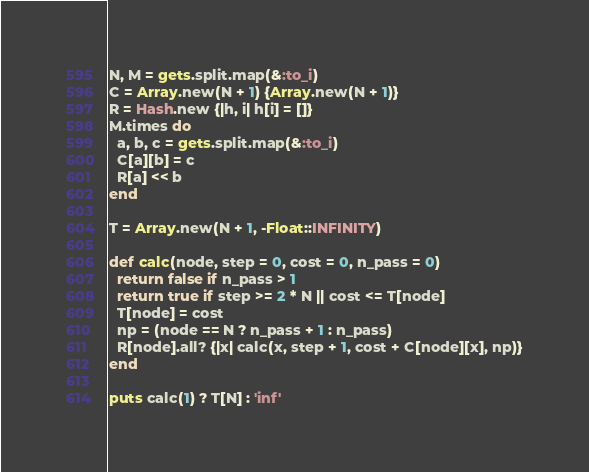<code> <loc_0><loc_0><loc_500><loc_500><_Ruby_>N, M = gets.split.map(&:to_i)
C = Array.new(N + 1) {Array.new(N + 1)}
R = Hash.new {|h, i| h[i] = []}
M.times do
  a, b, c = gets.split.map(&:to_i)
  C[a][b] = c
  R[a] << b
end
     
T = Array.new(N + 1, -Float::INFINITY)

def calc(node, step = 0, cost = 0, n_pass = 0)
  return false if n_pass > 1
  return true if step >= 2 * N || cost <= T[node]
  T[node] = cost
  np = (node == N ? n_pass + 1 : n_pass)
  R[node].all? {|x| calc(x, step + 1, cost + C[node][x], np)}
end
     
puts calc(1) ? T[N] : 'inf'</code> 